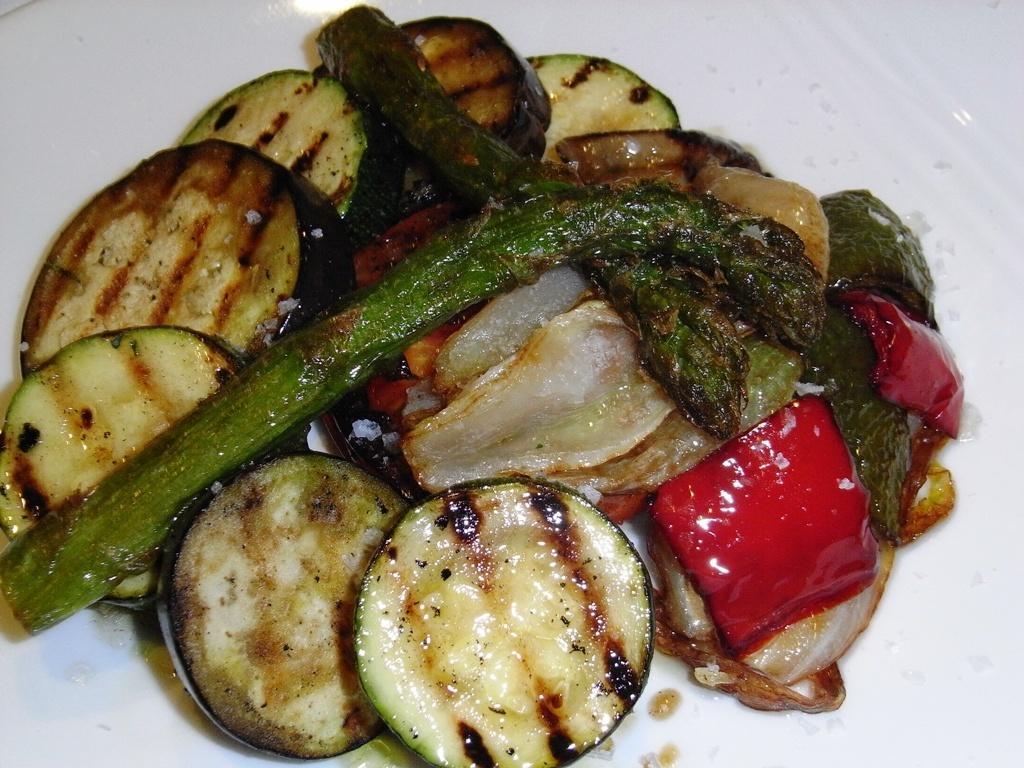Describe this image in one or two sentences. In the center of the image we can see food placed on the plate. 